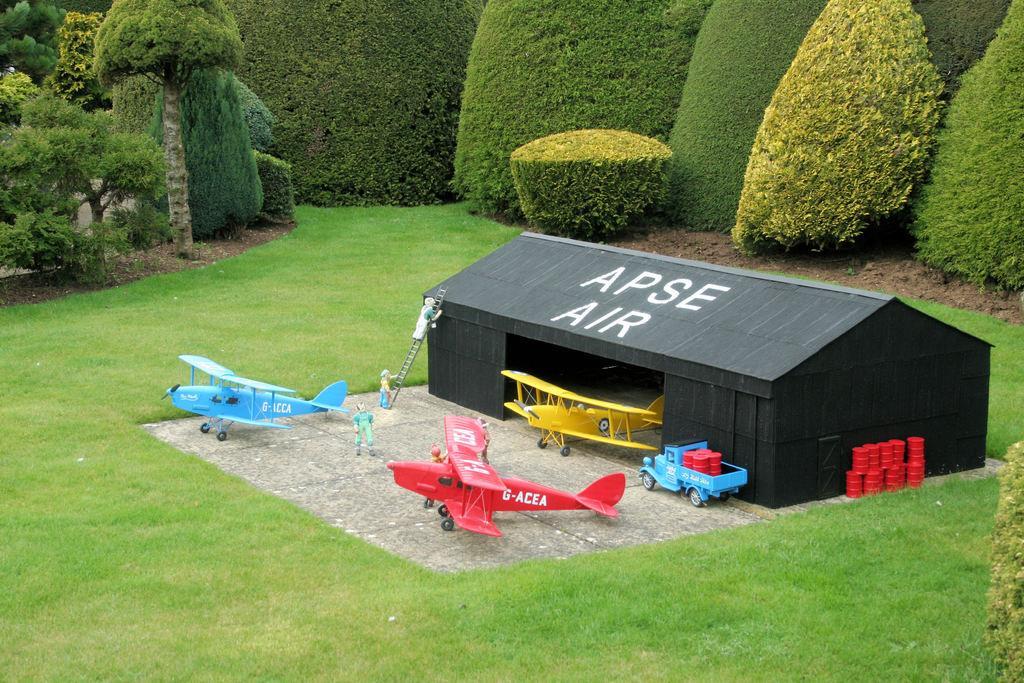In one or two sentences, can you explain what this image depicts? In this picture I can see the toys which are placed on the ground. In the center I can see the planes, trucks, drums, dolls, ladders and shed. In the background I can see many trees, plants and grass. 